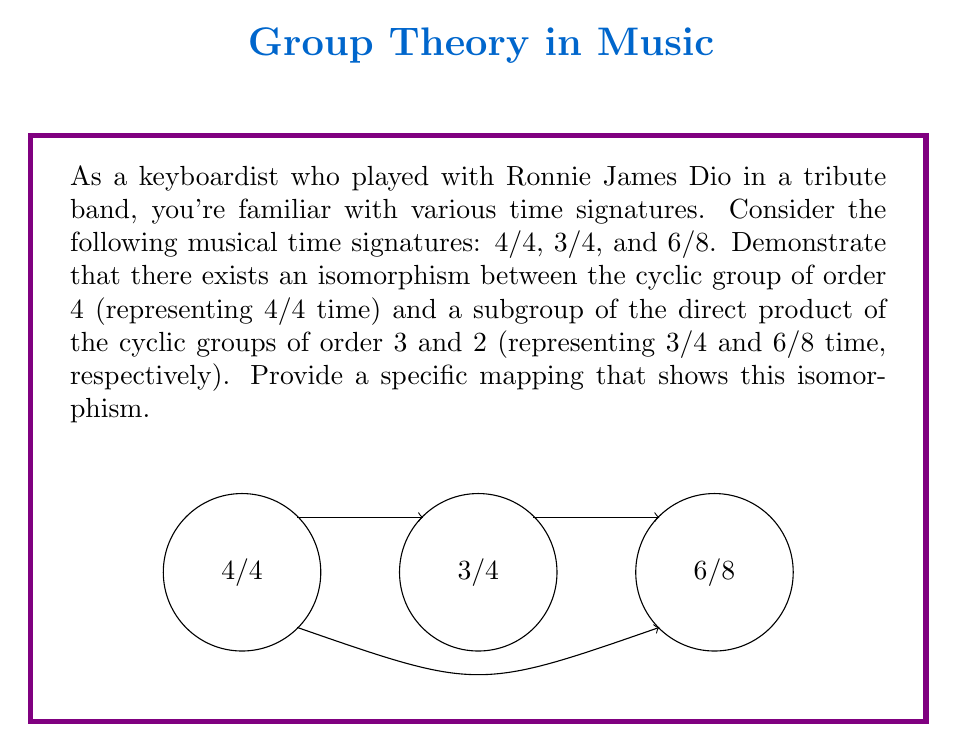What is the answer to this math problem? Let's approach this step-by-step:

1) First, let's define our groups:
   - Let $C_4$ be the cyclic group of order 4, representing 4/4 time.
   - Let $C_3$ be the cyclic group of order 3, representing 3/4 time.
   - Let $C_2$ be the cyclic group of order 2, representing 6/8 time.

2) We need to show an isomorphism between $C_4$ and a subgroup of $C_3 \times C_2$.

3) Let's define the elements of each group:
   $C_4 = \{0, 1, 2, 3\}$ (where 0 represents the first beat, 1 the second, etc.)
   $C_3 = \{0, 1, 2\}$
   $C_2 = \{0, 1\}$

4) Now, let's consider the direct product $C_3 \times C_2$:
   $C_3 \times C_2 = \{(0,0), (1,0), (2,0), (0,1), (1,1), (2,1)\}$

5) We need to find a subgroup of $C_3 \times C_2$ that has order 4. Let's consider the subgroup:
   $H = \{(0,0), (1,1), (2,0), (0,1)\}$

6) We can define an isomorphism $\phi: C_4 \rightarrow H$ as follows:
   $\phi(0) = (0,0)$
   $\phi(1) = (1,1)$
   $\phi(2) = (2,0)$
   $\phi(3) = (0,1)$

7) To prove this is an isomorphism, we need to show it's bijective and preserves the group operation.

8) Bijectivity is clear as $\phi$ maps each element of $C_4$ to a unique element of $H$, and every element of $H$ is mapped to.

9) To show it preserves the group operation, we need to check that $\phi(a + b \mod 4) = \phi(a) + \phi(b)$ for all $a, b \in C_4$. 
   For example: 
   $\phi(1 + 2 \mod 4) = \phi(3) = (0,1)$
   $\phi(1) + \phi(2) = (1,1) + (2,0) = (0,1)$

10) This holds for all combinations, thus $\phi$ is an isomorphism.

This isomorphism demonstrates how the 4/4 time signature can be represented in terms of 3/4 and 6/8, reflecting the musical relationship between these time signatures.
Answer: $\phi: C_4 \rightarrow H \subset C_3 \times C_2$, where $\phi(0) = (0,0)$, $\phi(1) = (1,1)$, $\phi(2) = (2,0)$, $\phi(3) = (0,1)$ 